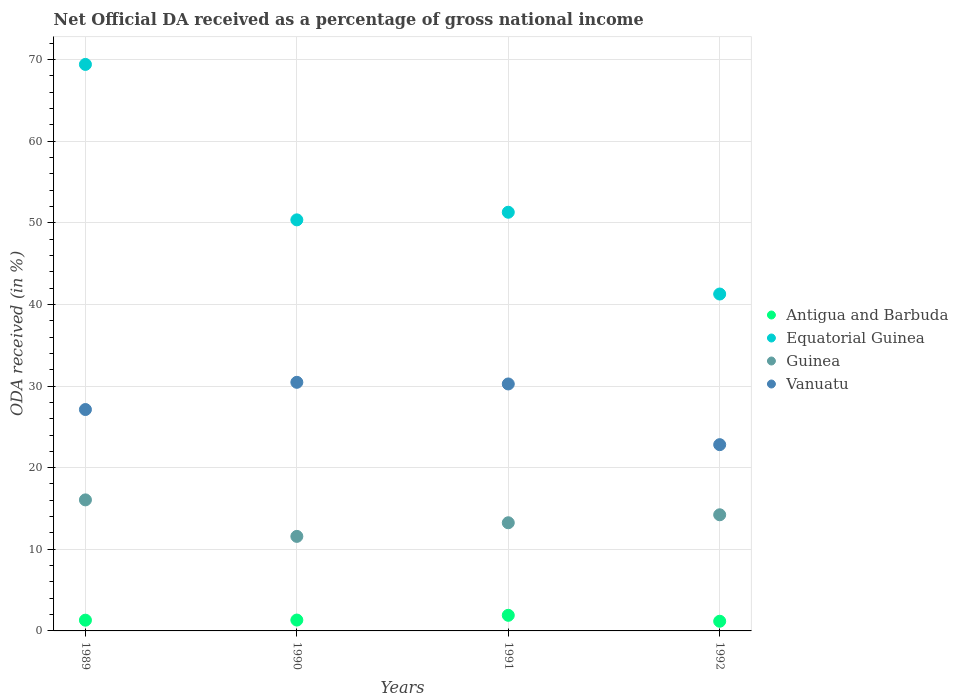Is the number of dotlines equal to the number of legend labels?
Your answer should be compact. Yes. What is the net official DA received in Equatorial Guinea in 1992?
Ensure brevity in your answer.  41.27. Across all years, what is the maximum net official DA received in Vanuatu?
Make the answer very short. 30.46. Across all years, what is the minimum net official DA received in Equatorial Guinea?
Your response must be concise. 41.27. In which year was the net official DA received in Vanuatu maximum?
Provide a succinct answer. 1990. What is the total net official DA received in Vanuatu in the graph?
Your answer should be very brief. 110.65. What is the difference between the net official DA received in Equatorial Guinea in 1990 and that in 1991?
Provide a short and direct response. -0.93. What is the difference between the net official DA received in Vanuatu in 1991 and the net official DA received in Antigua and Barbuda in 1989?
Provide a succinct answer. 28.94. What is the average net official DA received in Vanuatu per year?
Keep it short and to the point. 27.66. In the year 1989, what is the difference between the net official DA received in Guinea and net official DA received in Equatorial Guinea?
Offer a terse response. -53.35. In how many years, is the net official DA received in Antigua and Barbuda greater than 64 %?
Provide a succinct answer. 0. What is the ratio of the net official DA received in Guinea in 1991 to that in 1992?
Ensure brevity in your answer.  0.93. Is the difference between the net official DA received in Guinea in 1989 and 1990 greater than the difference between the net official DA received in Equatorial Guinea in 1989 and 1990?
Make the answer very short. No. What is the difference between the highest and the second highest net official DA received in Antigua and Barbuda?
Give a very brief answer. 0.58. What is the difference between the highest and the lowest net official DA received in Antigua and Barbuda?
Your response must be concise. 0.73. Is it the case that in every year, the sum of the net official DA received in Vanuatu and net official DA received in Antigua and Barbuda  is greater than the sum of net official DA received in Equatorial Guinea and net official DA received in Guinea?
Your answer should be very brief. No. Does the net official DA received in Guinea monotonically increase over the years?
Your response must be concise. No. Is the net official DA received in Vanuatu strictly greater than the net official DA received in Antigua and Barbuda over the years?
Provide a short and direct response. Yes. How many years are there in the graph?
Make the answer very short. 4. Are the values on the major ticks of Y-axis written in scientific E-notation?
Keep it short and to the point. No. Does the graph contain any zero values?
Offer a very short reply. No. Does the graph contain grids?
Your answer should be compact. Yes. How many legend labels are there?
Offer a terse response. 4. What is the title of the graph?
Keep it short and to the point. Net Official DA received as a percentage of gross national income. Does "Cambodia" appear as one of the legend labels in the graph?
Offer a terse response. No. What is the label or title of the X-axis?
Make the answer very short. Years. What is the label or title of the Y-axis?
Provide a succinct answer. ODA received (in %). What is the ODA received (in %) of Antigua and Barbuda in 1989?
Provide a succinct answer. 1.32. What is the ODA received (in %) of Equatorial Guinea in 1989?
Your answer should be compact. 69.4. What is the ODA received (in %) of Guinea in 1989?
Your answer should be very brief. 16.05. What is the ODA received (in %) in Vanuatu in 1989?
Ensure brevity in your answer.  27.12. What is the ODA received (in %) in Antigua and Barbuda in 1990?
Make the answer very short. 1.33. What is the ODA received (in %) in Equatorial Guinea in 1990?
Provide a succinct answer. 50.36. What is the ODA received (in %) in Guinea in 1990?
Make the answer very short. 11.58. What is the ODA received (in %) of Vanuatu in 1990?
Offer a terse response. 30.46. What is the ODA received (in %) in Antigua and Barbuda in 1991?
Keep it short and to the point. 1.91. What is the ODA received (in %) of Equatorial Guinea in 1991?
Provide a succinct answer. 51.29. What is the ODA received (in %) of Guinea in 1991?
Ensure brevity in your answer.  13.25. What is the ODA received (in %) in Vanuatu in 1991?
Provide a short and direct response. 30.26. What is the ODA received (in %) of Antigua and Barbuda in 1992?
Your answer should be very brief. 1.19. What is the ODA received (in %) of Equatorial Guinea in 1992?
Provide a short and direct response. 41.27. What is the ODA received (in %) of Guinea in 1992?
Your response must be concise. 14.23. What is the ODA received (in %) of Vanuatu in 1992?
Offer a very short reply. 22.82. Across all years, what is the maximum ODA received (in %) of Antigua and Barbuda?
Your answer should be compact. 1.91. Across all years, what is the maximum ODA received (in %) in Equatorial Guinea?
Provide a succinct answer. 69.4. Across all years, what is the maximum ODA received (in %) in Guinea?
Ensure brevity in your answer.  16.05. Across all years, what is the maximum ODA received (in %) in Vanuatu?
Provide a short and direct response. 30.46. Across all years, what is the minimum ODA received (in %) of Antigua and Barbuda?
Provide a short and direct response. 1.19. Across all years, what is the minimum ODA received (in %) in Equatorial Guinea?
Make the answer very short. 41.27. Across all years, what is the minimum ODA received (in %) of Guinea?
Ensure brevity in your answer.  11.58. Across all years, what is the minimum ODA received (in %) of Vanuatu?
Your response must be concise. 22.82. What is the total ODA received (in %) of Antigua and Barbuda in the graph?
Keep it short and to the point. 5.74. What is the total ODA received (in %) of Equatorial Guinea in the graph?
Ensure brevity in your answer.  212.32. What is the total ODA received (in %) of Guinea in the graph?
Give a very brief answer. 55.11. What is the total ODA received (in %) of Vanuatu in the graph?
Ensure brevity in your answer.  110.65. What is the difference between the ODA received (in %) of Antigua and Barbuda in 1989 and that in 1990?
Give a very brief answer. -0.02. What is the difference between the ODA received (in %) of Equatorial Guinea in 1989 and that in 1990?
Your answer should be very brief. 19.04. What is the difference between the ODA received (in %) of Guinea in 1989 and that in 1990?
Provide a succinct answer. 4.47. What is the difference between the ODA received (in %) of Vanuatu in 1989 and that in 1990?
Make the answer very short. -3.33. What is the difference between the ODA received (in %) in Antigua and Barbuda in 1989 and that in 1991?
Keep it short and to the point. -0.6. What is the difference between the ODA received (in %) of Equatorial Guinea in 1989 and that in 1991?
Offer a very short reply. 18.11. What is the difference between the ODA received (in %) in Guinea in 1989 and that in 1991?
Provide a succinct answer. 2.8. What is the difference between the ODA received (in %) in Vanuatu in 1989 and that in 1991?
Give a very brief answer. -3.13. What is the difference between the ODA received (in %) of Antigua and Barbuda in 1989 and that in 1992?
Provide a succinct answer. 0.13. What is the difference between the ODA received (in %) in Equatorial Guinea in 1989 and that in 1992?
Ensure brevity in your answer.  28.13. What is the difference between the ODA received (in %) in Guinea in 1989 and that in 1992?
Your answer should be very brief. 1.83. What is the difference between the ODA received (in %) in Vanuatu in 1989 and that in 1992?
Your answer should be compact. 4.3. What is the difference between the ODA received (in %) of Antigua and Barbuda in 1990 and that in 1991?
Your response must be concise. -0.58. What is the difference between the ODA received (in %) in Equatorial Guinea in 1990 and that in 1991?
Provide a short and direct response. -0.93. What is the difference between the ODA received (in %) of Guinea in 1990 and that in 1991?
Provide a short and direct response. -1.67. What is the difference between the ODA received (in %) in Vanuatu in 1990 and that in 1991?
Make the answer very short. 0.2. What is the difference between the ODA received (in %) of Antigua and Barbuda in 1990 and that in 1992?
Your answer should be compact. 0.15. What is the difference between the ODA received (in %) of Equatorial Guinea in 1990 and that in 1992?
Offer a very short reply. 9.09. What is the difference between the ODA received (in %) of Guinea in 1990 and that in 1992?
Give a very brief answer. -2.65. What is the difference between the ODA received (in %) in Vanuatu in 1990 and that in 1992?
Make the answer very short. 7.64. What is the difference between the ODA received (in %) in Antigua and Barbuda in 1991 and that in 1992?
Keep it short and to the point. 0.73. What is the difference between the ODA received (in %) in Equatorial Guinea in 1991 and that in 1992?
Provide a succinct answer. 10.02. What is the difference between the ODA received (in %) of Guinea in 1991 and that in 1992?
Make the answer very short. -0.98. What is the difference between the ODA received (in %) in Vanuatu in 1991 and that in 1992?
Your answer should be compact. 7.44. What is the difference between the ODA received (in %) in Antigua and Barbuda in 1989 and the ODA received (in %) in Equatorial Guinea in 1990?
Keep it short and to the point. -49.04. What is the difference between the ODA received (in %) in Antigua and Barbuda in 1989 and the ODA received (in %) in Guinea in 1990?
Provide a short and direct response. -10.27. What is the difference between the ODA received (in %) of Antigua and Barbuda in 1989 and the ODA received (in %) of Vanuatu in 1990?
Make the answer very short. -29.14. What is the difference between the ODA received (in %) of Equatorial Guinea in 1989 and the ODA received (in %) of Guinea in 1990?
Ensure brevity in your answer.  57.82. What is the difference between the ODA received (in %) in Equatorial Guinea in 1989 and the ODA received (in %) in Vanuatu in 1990?
Offer a very short reply. 38.94. What is the difference between the ODA received (in %) in Guinea in 1989 and the ODA received (in %) in Vanuatu in 1990?
Your response must be concise. -14.4. What is the difference between the ODA received (in %) in Antigua and Barbuda in 1989 and the ODA received (in %) in Equatorial Guinea in 1991?
Ensure brevity in your answer.  -49.98. What is the difference between the ODA received (in %) of Antigua and Barbuda in 1989 and the ODA received (in %) of Guinea in 1991?
Keep it short and to the point. -11.94. What is the difference between the ODA received (in %) in Antigua and Barbuda in 1989 and the ODA received (in %) in Vanuatu in 1991?
Keep it short and to the point. -28.94. What is the difference between the ODA received (in %) in Equatorial Guinea in 1989 and the ODA received (in %) in Guinea in 1991?
Give a very brief answer. 56.15. What is the difference between the ODA received (in %) in Equatorial Guinea in 1989 and the ODA received (in %) in Vanuatu in 1991?
Your answer should be very brief. 39.15. What is the difference between the ODA received (in %) of Guinea in 1989 and the ODA received (in %) of Vanuatu in 1991?
Offer a very short reply. -14.2. What is the difference between the ODA received (in %) of Antigua and Barbuda in 1989 and the ODA received (in %) of Equatorial Guinea in 1992?
Give a very brief answer. -39.96. What is the difference between the ODA received (in %) of Antigua and Barbuda in 1989 and the ODA received (in %) of Guinea in 1992?
Give a very brief answer. -12.91. What is the difference between the ODA received (in %) of Antigua and Barbuda in 1989 and the ODA received (in %) of Vanuatu in 1992?
Provide a succinct answer. -21.5. What is the difference between the ODA received (in %) of Equatorial Guinea in 1989 and the ODA received (in %) of Guinea in 1992?
Give a very brief answer. 55.17. What is the difference between the ODA received (in %) of Equatorial Guinea in 1989 and the ODA received (in %) of Vanuatu in 1992?
Keep it short and to the point. 46.58. What is the difference between the ODA received (in %) in Guinea in 1989 and the ODA received (in %) in Vanuatu in 1992?
Your answer should be very brief. -6.76. What is the difference between the ODA received (in %) of Antigua and Barbuda in 1990 and the ODA received (in %) of Equatorial Guinea in 1991?
Offer a terse response. -49.96. What is the difference between the ODA received (in %) of Antigua and Barbuda in 1990 and the ODA received (in %) of Guinea in 1991?
Make the answer very short. -11.92. What is the difference between the ODA received (in %) in Antigua and Barbuda in 1990 and the ODA received (in %) in Vanuatu in 1991?
Give a very brief answer. -28.92. What is the difference between the ODA received (in %) of Equatorial Guinea in 1990 and the ODA received (in %) of Guinea in 1991?
Make the answer very short. 37.11. What is the difference between the ODA received (in %) in Equatorial Guinea in 1990 and the ODA received (in %) in Vanuatu in 1991?
Give a very brief answer. 20.1. What is the difference between the ODA received (in %) in Guinea in 1990 and the ODA received (in %) in Vanuatu in 1991?
Offer a very short reply. -18.67. What is the difference between the ODA received (in %) of Antigua and Barbuda in 1990 and the ODA received (in %) of Equatorial Guinea in 1992?
Provide a succinct answer. -39.94. What is the difference between the ODA received (in %) of Antigua and Barbuda in 1990 and the ODA received (in %) of Guinea in 1992?
Give a very brief answer. -12.9. What is the difference between the ODA received (in %) of Antigua and Barbuda in 1990 and the ODA received (in %) of Vanuatu in 1992?
Make the answer very short. -21.49. What is the difference between the ODA received (in %) of Equatorial Guinea in 1990 and the ODA received (in %) of Guinea in 1992?
Provide a short and direct response. 36.13. What is the difference between the ODA received (in %) in Equatorial Guinea in 1990 and the ODA received (in %) in Vanuatu in 1992?
Offer a terse response. 27.54. What is the difference between the ODA received (in %) in Guinea in 1990 and the ODA received (in %) in Vanuatu in 1992?
Provide a succinct answer. -11.24. What is the difference between the ODA received (in %) in Antigua and Barbuda in 1991 and the ODA received (in %) in Equatorial Guinea in 1992?
Ensure brevity in your answer.  -39.36. What is the difference between the ODA received (in %) in Antigua and Barbuda in 1991 and the ODA received (in %) in Guinea in 1992?
Your answer should be compact. -12.32. What is the difference between the ODA received (in %) in Antigua and Barbuda in 1991 and the ODA received (in %) in Vanuatu in 1992?
Provide a succinct answer. -20.91. What is the difference between the ODA received (in %) of Equatorial Guinea in 1991 and the ODA received (in %) of Guinea in 1992?
Your answer should be compact. 37.06. What is the difference between the ODA received (in %) of Equatorial Guinea in 1991 and the ODA received (in %) of Vanuatu in 1992?
Your answer should be compact. 28.47. What is the difference between the ODA received (in %) of Guinea in 1991 and the ODA received (in %) of Vanuatu in 1992?
Provide a short and direct response. -9.57. What is the average ODA received (in %) of Antigua and Barbuda per year?
Offer a terse response. 1.44. What is the average ODA received (in %) in Equatorial Guinea per year?
Ensure brevity in your answer.  53.08. What is the average ODA received (in %) of Guinea per year?
Give a very brief answer. 13.78. What is the average ODA received (in %) in Vanuatu per year?
Your response must be concise. 27.66. In the year 1989, what is the difference between the ODA received (in %) of Antigua and Barbuda and ODA received (in %) of Equatorial Guinea?
Your answer should be compact. -68.09. In the year 1989, what is the difference between the ODA received (in %) in Antigua and Barbuda and ODA received (in %) in Guinea?
Make the answer very short. -14.74. In the year 1989, what is the difference between the ODA received (in %) in Antigua and Barbuda and ODA received (in %) in Vanuatu?
Your answer should be compact. -25.81. In the year 1989, what is the difference between the ODA received (in %) of Equatorial Guinea and ODA received (in %) of Guinea?
Your answer should be compact. 53.35. In the year 1989, what is the difference between the ODA received (in %) of Equatorial Guinea and ODA received (in %) of Vanuatu?
Your answer should be compact. 42.28. In the year 1989, what is the difference between the ODA received (in %) in Guinea and ODA received (in %) in Vanuatu?
Keep it short and to the point. -11.07. In the year 1990, what is the difference between the ODA received (in %) of Antigua and Barbuda and ODA received (in %) of Equatorial Guinea?
Your answer should be very brief. -49.03. In the year 1990, what is the difference between the ODA received (in %) of Antigua and Barbuda and ODA received (in %) of Guinea?
Make the answer very short. -10.25. In the year 1990, what is the difference between the ODA received (in %) of Antigua and Barbuda and ODA received (in %) of Vanuatu?
Provide a short and direct response. -29.13. In the year 1990, what is the difference between the ODA received (in %) of Equatorial Guinea and ODA received (in %) of Guinea?
Offer a terse response. 38.78. In the year 1990, what is the difference between the ODA received (in %) in Equatorial Guinea and ODA received (in %) in Vanuatu?
Your answer should be compact. 19.9. In the year 1990, what is the difference between the ODA received (in %) of Guinea and ODA received (in %) of Vanuatu?
Provide a short and direct response. -18.88. In the year 1991, what is the difference between the ODA received (in %) of Antigua and Barbuda and ODA received (in %) of Equatorial Guinea?
Give a very brief answer. -49.38. In the year 1991, what is the difference between the ODA received (in %) in Antigua and Barbuda and ODA received (in %) in Guinea?
Give a very brief answer. -11.34. In the year 1991, what is the difference between the ODA received (in %) in Antigua and Barbuda and ODA received (in %) in Vanuatu?
Keep it short and to the point. -28.34. In the year 1991, what is the difference between the ODA received (in %) of Equatorial Guinea and ODA received (in %) of Guinea?
Ensure brevity in your answer.  38.04. In the year 1991, what is the difference between the ODA received (in %) in Equatorial Guinea and ODA received (in %) in Vanuatu?
Offer a very short reply. 21.04. In the year 1991, what is the difference between the ODA received (in %) of Guinea and ODA received (in %) of Vanuatu?
Your response must be concise. -17. In the year 1992, what is the difference between the ODA received (in %) of Antigua and Barbuda and ODA received (in %) of Equatorial Guinea?
Your answer should be very brief. -40.09. In the year 1992, what is the difference between the ODA received (in %) in Antigua and Barbuda and ODA received (in %) in Guinea?
Give a very brief answer. -13.04. In the year 1992, what is the difference between the ODA received (in %) of Antigua and Barbuda and ODA received (in %) of Vanuatu?
Offer a terse response. -21.63. In the year 1992, what is the difference between the ODA received (in %) of Equatorial Guinea and ODA received (in %) of Guinea?
Provide a short and direct response. 27.04. In the year 1992, what is the difference between the ODA received (in %) in Equatorial Guinea and ODA received (in %) in Vanuatu?
Offer a very short reply. 18.45. In the year 1992, what is the difference between the ODA received (in %) of Guinea and ODA received (in %) of Vanuatu?
Offer a very short reply. -8.59. What is the ratio of the ODA received (in %) of Antigua and Barbuda in 1989 to that in 1990?
Provide a succinct answer. 0.99. What is the ratio of the ODA received (in %) of Equatorial Guinea in 1989 to that in 1990?
Offer a terse response. 1.38. What is the ratio of the ODA received (in %) of Guinea in 1989 to that in 1990?
Offer a terse response. 1.39. What is the ratio of the ODA received (in %) in Vanuatu in 1989 to that in 1990?
Offer a terse response. 0.89. What is the ratio of the ODA received (in %) of Antigua and Barbuda in 1989 to that in 1991?
Provide a succinct answer. 0.69. What is the ratio of the ODA received (in %) in Equatorial Guinea in 1989 to that in 1991?
Provide a short and direct response. 1.35. What is the ratio of the ODA received (in %) in Guinea in 1989 to that in 1991?
Offer a terse response. 1.21. What is the ratio of the ODA received (in %) in Vanuatu in 1989 to that in 1991?
Offer a terse response. 0.9. What is the ratio of the ODA received (in %) in Antigua and Barbuda in 1989 to that in 1992?
Your answer should be very brief. 1.11. What is the ratio of the ODA received (in %) of Equatorial Guinea in 1989 to that in 1992?
Offer a terse response. 1.68. What is the ratio of the ODA received (in %) of Guinea in 1989 to that in 1992?
Your response must be concise. 1.13. What is the ratio of the ODA received (in %) in Vanuatu in 1989 to that in 1992?
Your answer should be compact. 1.19. What is the ratio of the ODA received (in %) in Antigua and Barbuda in 1990 to that in 1991?
Ensure brevity in your answer.  0.7. What is the ratio of the ODA received (in %) in Equatorial Guinea in 1990 to that in 1991?
Keep it short and to the point. 0.98. What is the ratio of the ODA received (in %) in Guinea in 1990 to that in 1991?
Your response must be concise. 0.87. What is the ratio of the ODA received (in %) in Vanuatu in 1990 to that in 1991?
Provide a short and direct response. 1.01. What is the ratio of the ODA received (in %) of Antigua and Barbuda in 1990 to that in 1992?
Provide a succinct answer. 1.12. What is the ratio of the ODA received (in %) of Equatorial Guinea in 1990 to that in 1992?
Offer a terse response. 1.22. What is the ratio of the ODA received (in %) of Guinea in 1990 to that in 1992?
Keep it short and to the point. 0.81. What is the ratio of the ODA received (in %) in Vanuatu in 1990 to that in 1992?
Offer a very short reply. 1.33. What is the ratio of the ODA received (in %) of Antigua and Barbuda in 1991 to that in 1992?
Your response must be concise. 1.61. What is the ratio of the ODA received (in %) of Equatorial Guinea in 1991 to that in 1992?
Your response must be concise. 1.24. What is the ratio of the ODA received (in %) of Guinea in 1991 to that in 1992?
Offer a very short reply. 0.93. What is the ratio of the ODA received (in %) in Vanuatu in 1991 to that in 1992?
Provide a succinct answer. 1.33. What is the difference between the highest and the second highest ODA received (in %) of Antigua and Barbuda?
Keep it short and to the point. 0.58. What is the difference between the highest and the second highest ODA received (in %) in Equatorial Guinea?
Your answer should be very brief. 18.11. What is the difference between the highest and the second highest ODA received (in %) of Guinea?
Your answer should be compact. 1.83. What is the difference between the highest and the second highest ODA received (in %) of Vanuatu?
Your answer should be very brief. 0.2. What is the difference between the highest and the lowest ODA received (in %) of Antigua and Barbuda?
Provide a short and direct response. 0.73. What is the difference between the highest and the lowest ODA received (in %) in Equatorial Guinea?
Keep it short and to the point. 28.13. What is the difference between the highest and the lowest ODA received (in %) in Guinea?
Your answer should be compact. 4.47. What is the difference between the highest and the lowest ODA received (in %) of Vanuatu?
Offer a very short reply. 7.64. 